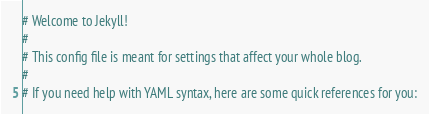Convert code to text. <code><loc_0><loc_0><loc_500><loc_500><_YAML_># Welcome to Jekyll!
#
# This config file is meant for settings that affect your whole blog.
#
# If you need help with YAML syntax, here are some quick references for you:</code> 